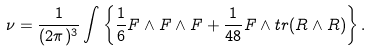Convert formula to latex. <formula><loc_0><loc_0><loc_500><loc_500>\nu = { \frac { 1 } { ( 2 \pi ) ^ { 3 } } } \int \left \{ { \frac { 1 } { 6 } } F \wedge F \wedge F + { \frac { 1 } { 4 8 } } F \wedge t r ( R \wedge R ) \right \} .</formula> 